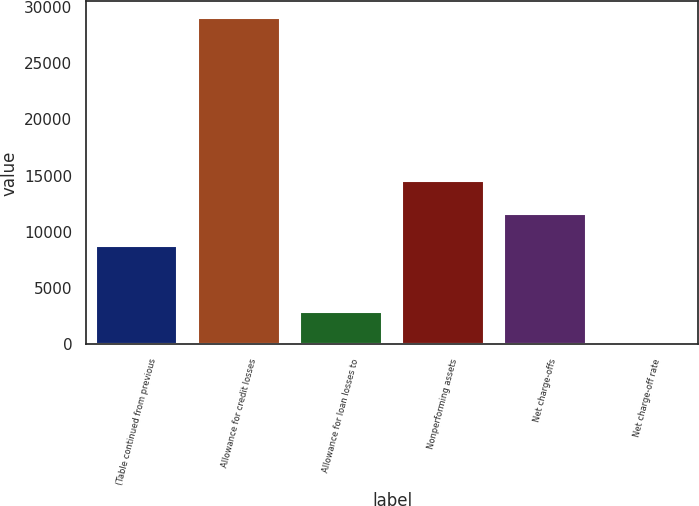<chart> <loc_0><loc_0><loc_500><loc_500><bar_chart><fcel>(Table continued from previous<fcel>Allowance for credit losses<fcel>Allowance for loan losses to<fcel>Nonperforming assets<fcel>Net charge-offs<fcel>Net charge-off rate<nl><fcel>8711.82<fcel>29036<fcel>2904.9<fcel>14518.7<fcel>11615.3<fcel>1.44<nl></chart> 